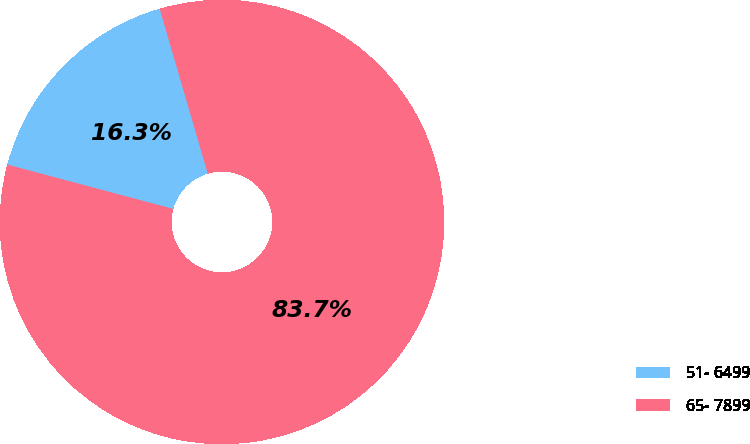Convert chart. <chart><loc_0><loc_0><loc_500><loc_500><pie_chart><fcel>51- 6499<fcel>65- 7899<nl><fcel>16.33%<fcel>83.67%<nl></chart> 